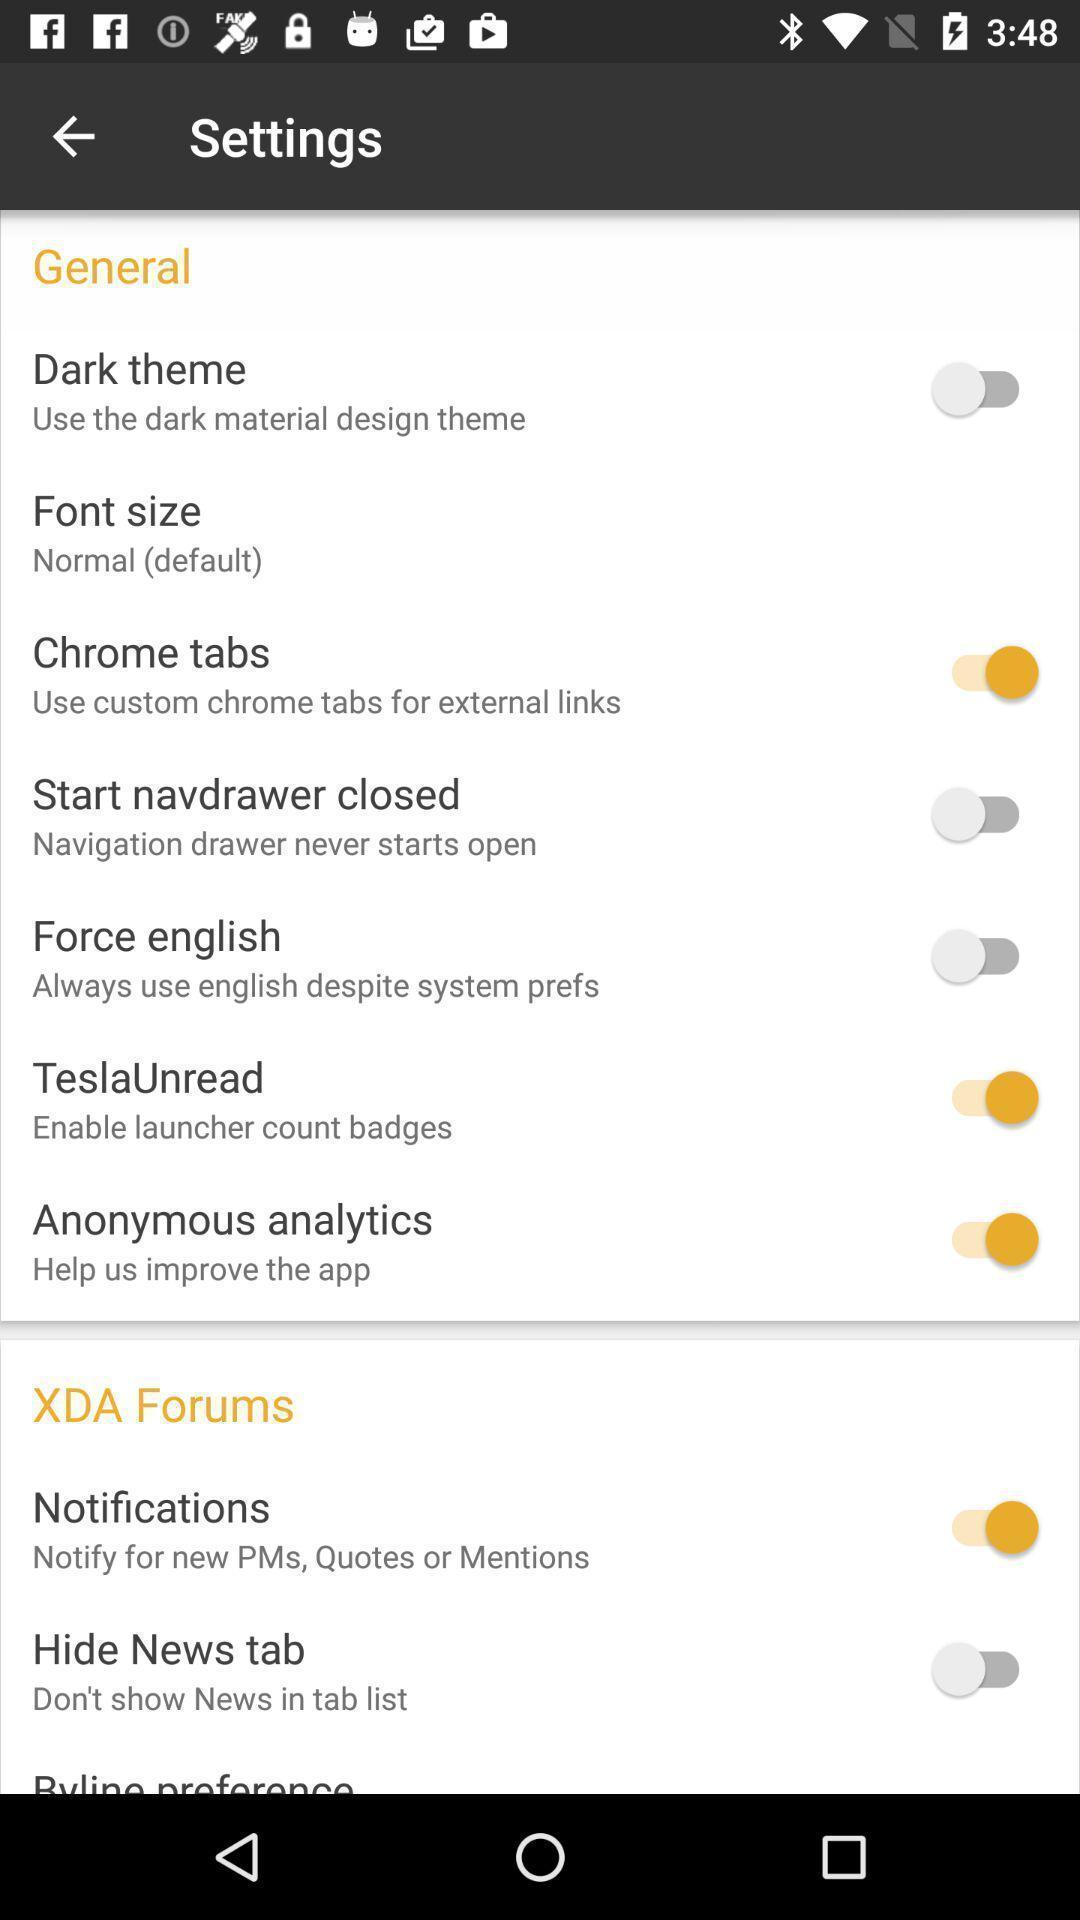Give me a summary of this screen capture. Settings page. 